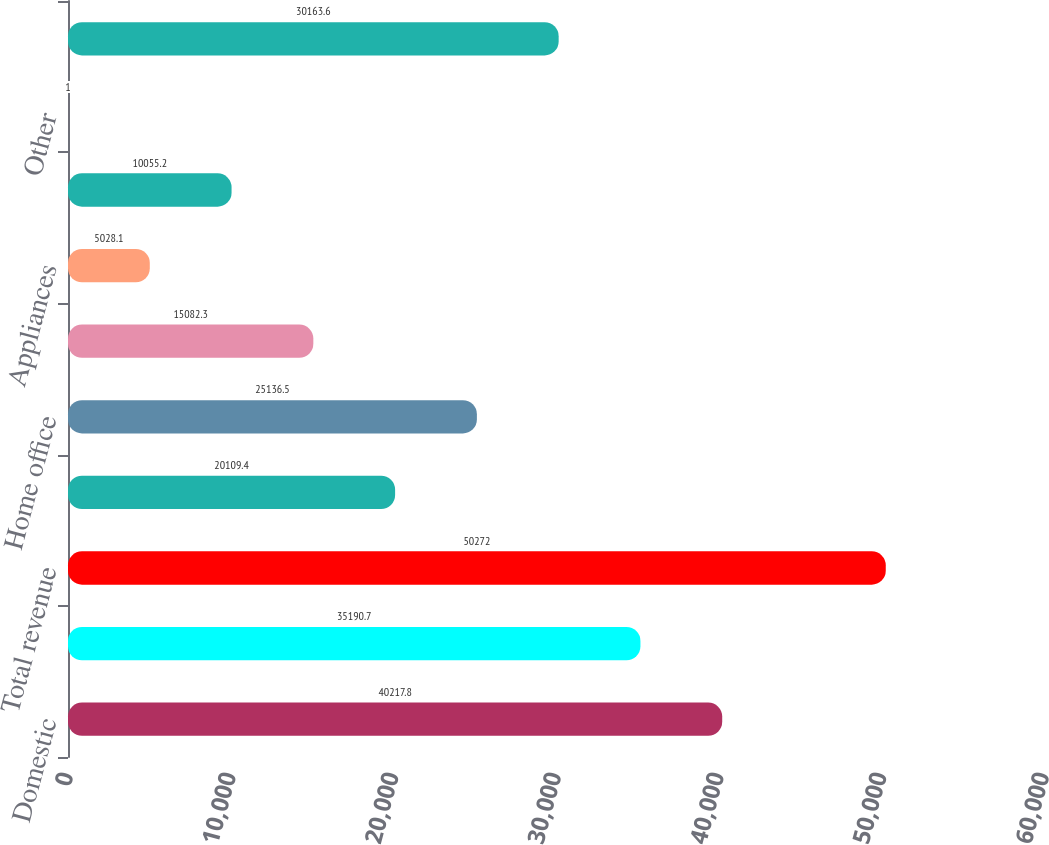<chart> <loc_0><loc_0><loc_500><loc_500><bar_chart><fcel>Domestic<fcel>International<fcel>Total revenue<fcel>Consumer electronics<fcel>Home office<fcel>Entertainment<fcel>Appliances<fcel>Services<fcel>Other<fcel>Total<nl><fcel>40217.8<fcel>35190.7<fcel>50272<fcel>20109.4<fcel>25136.5<fcel>15082.3<fcel>5028.1<fcel>10055.2<fcel>1<fcel>30163.6<nl></chart> 